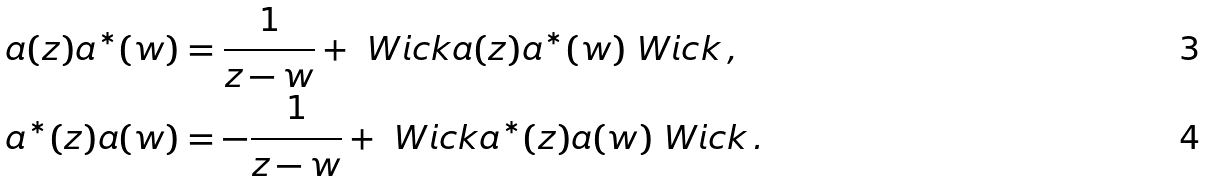<formula> <loc_0><loc_0><loc_500><loc_500>a ( z ) a ^ { * } ( w ) & = \frac { 1 } { z - w } + \ W i c k a ( z ) a ^ { * } ( w ) \ W i c k \, , \\ a ^ { * } ( z ) a ( w ) & = - \frac { 1 } { z - w } + \ W i c k a ^ { * } ( z ) a ( w ) \ W i c k \, .</formula> 